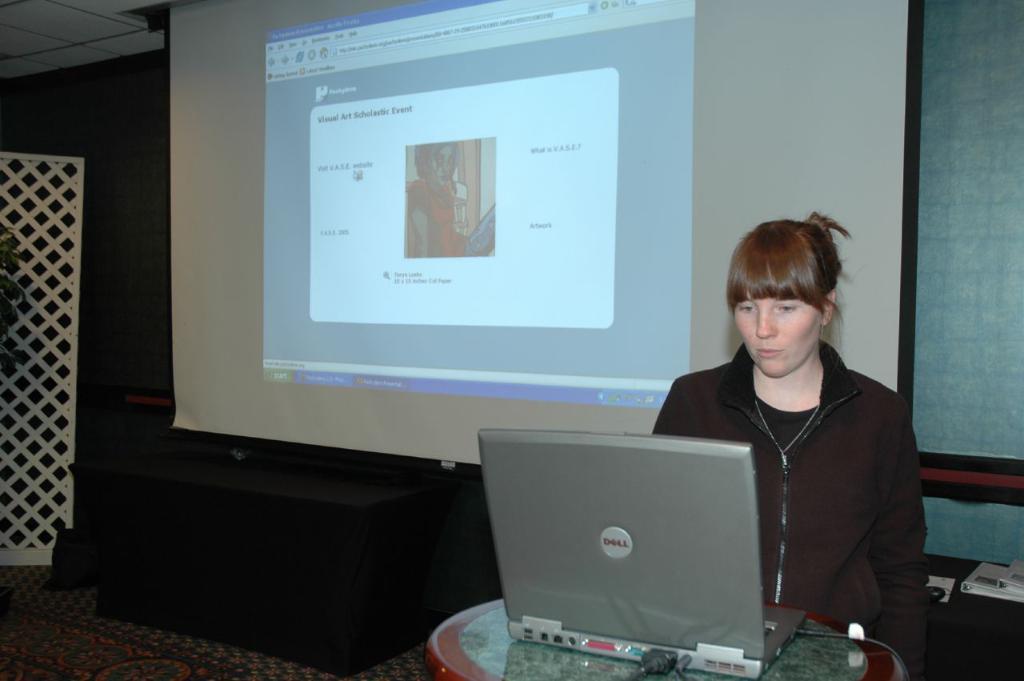Describe this image in one or two sentences. In the image on the right we can see one woman standing. In front of her,we can see one table and laptop. In the background there is a wall,roof,screen,table,mouse,fence,plant,carpet and files. 